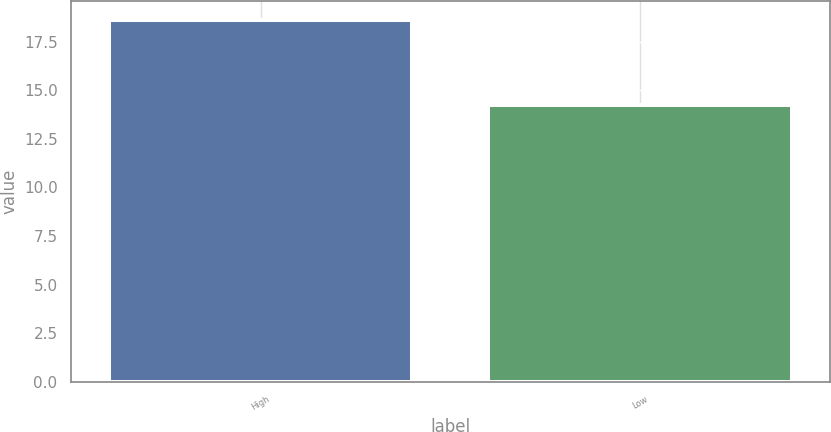Convert chart to OTSL. <chart><loc_0><loc_0><loc_500><loc_500><bar_chart><fcel>High<fcel>Low<nl><fcel>18.64<fcel>14.23<nl></chart> 